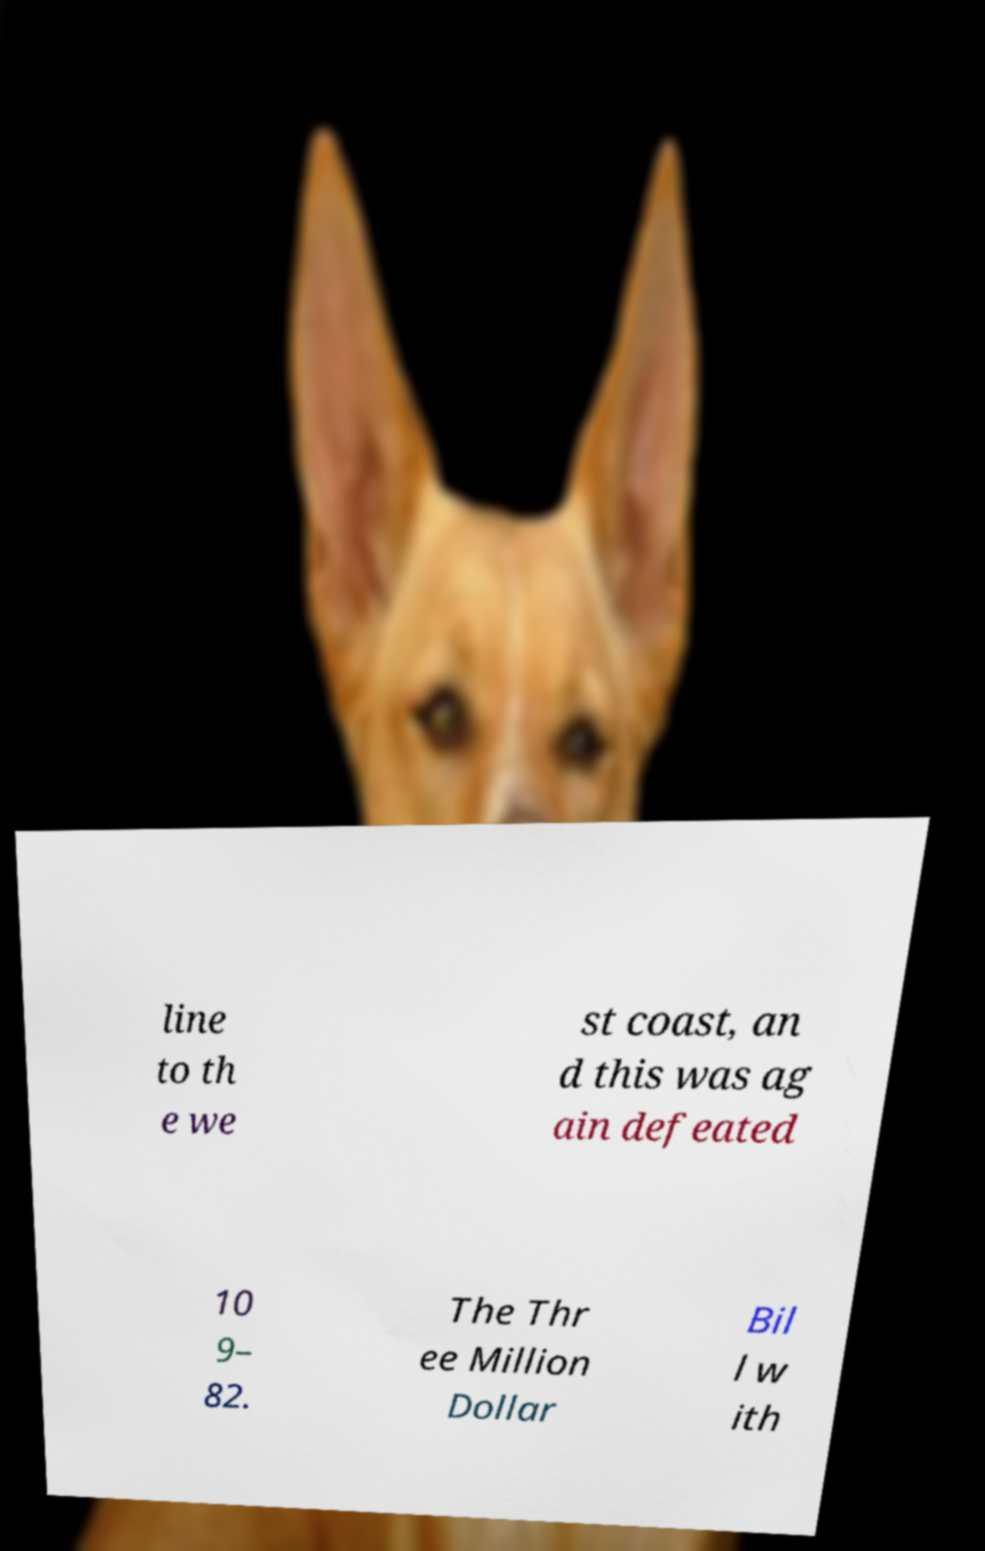Please identify and transcribe the text found in this image. line to th e we st coast, an d this was ag ain defeated 10 9– 82. The Thr ee Million Dollar Bil l w ith 